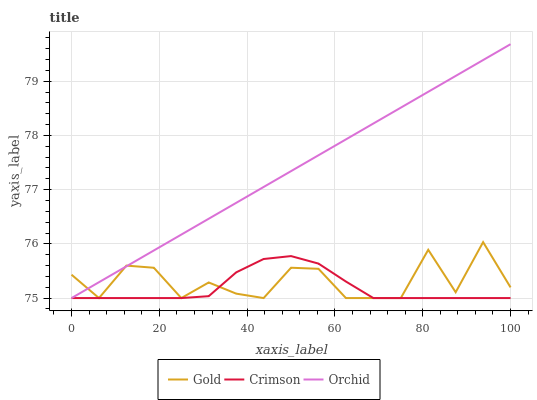Does Crimson have the minimum area under the curve?
Answer yes or no. Yes. Does Orchid have the maximum area under the curve?
Answer yes or no. Yes. Does Gold have the minimum area under the curve?
Answer yes or no. No. Does Gold have the maximum area under the curve?
Answer yes or no. No. Is Orchid the smoothest?
Answer yes or no. Yes. Is Gold the roughest?
Answer yes or no. Yes. Is Gold the smoothest?
Answer yes or no. No. Is Orchid the roughest?
Answer yes or no. No. Does Orchid have the highest value?
Answer yes or no. Yes. Does Gold have the highest value?
Answer yes or no. No. Does Crimson intersect Orchid?
Answer yes or no. Yes. Is Crimson less than Orchid?
Answer yes or no. No. Is Crimson greater than Orchid?
Answer yes or no. No. 